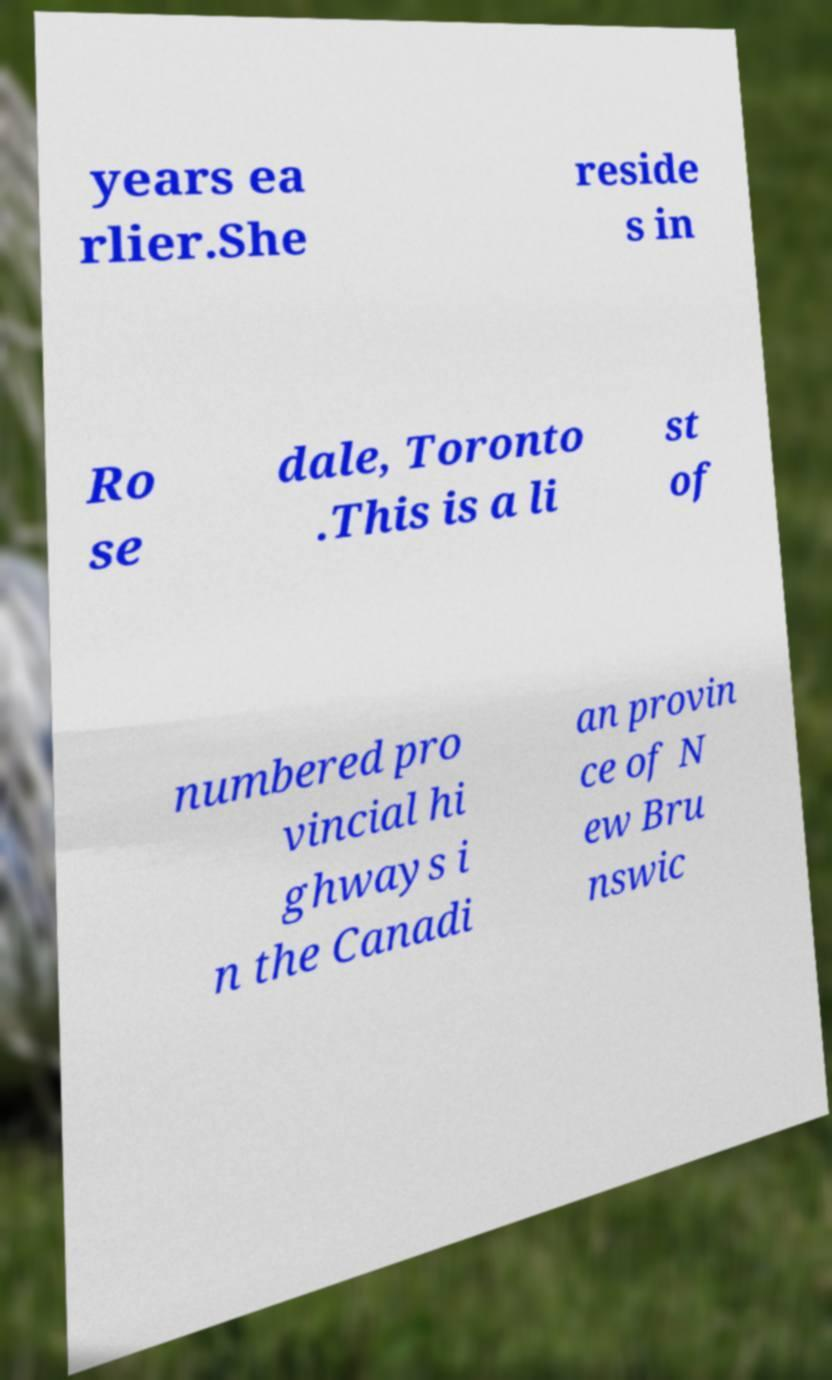What messages or text are displayed in this image? I need them in a readable, typed format. years ea rlier.She reside s in Ro se dale, Toronto .This is a li st of numbered pro vincial hi ghways i n the Canadi an provin ce of N ew Bru nswic 